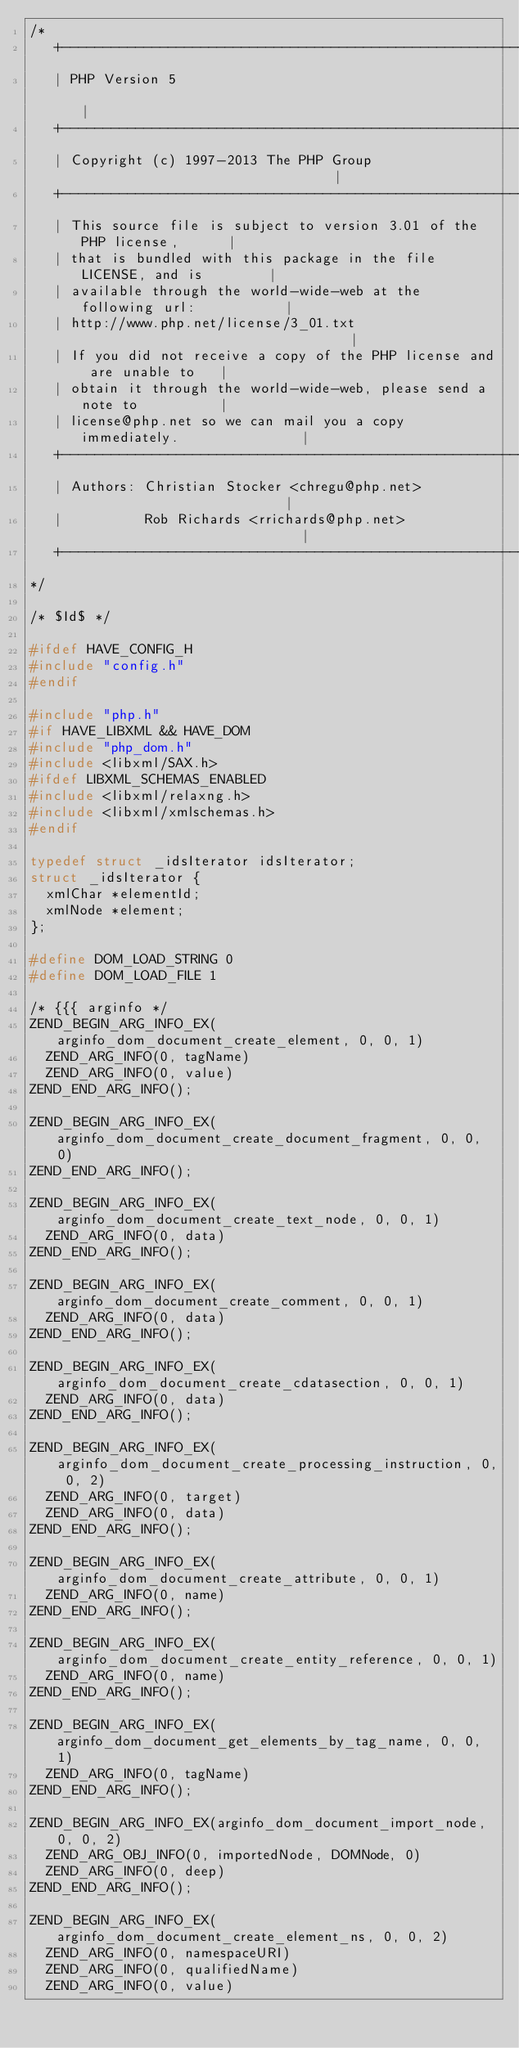Convert code to text. <code><loc_0><loc_0><loc_500><loc_500><_C_>/*
   +----------------------------------------------------------------------+
   | PHP Version 5                                                        |
   +----------------------------------------------------------------------+
   | Copyright (c) 1997-2013 The PHP Group                                |
   +----------------------------------------------------------------------+
   | This source file is subject to version 3.01 of the PHP license,      |
   | that is bundled with this package in the file LICENSE, and is        |
   | available through the world-wide-web at the following url:           |
   | http://www.php.net/license/3_01.txt                                  |
   | If you did not receive a copy of the PHP license and are unable to   |
   | obtain it through the world-wide-web, please send a note to          |
   | license@php.net so we can mail you a copy immediately.               |
   +----------------------------------------------------------------------+
   | Authors: Christian Stocker <chregu@php.net>                          |
   |          Rob Richards <rrichards@php.net>                            |
   +----------------------------------------------------------------------+
*/

/* $Id$ */

#ifdef HAVE_CONFIG_H
#include "config.h"
#endif

#include "php.h"
#if HAVE_LIBXML && HAVE_DOM
#include "php_dom.h"
#include <libxml/SAX.h>
#ifdef LIBXML_SCHEMAS_ENABLED
#include <libxml/relaxng.h>
#include <libxml/xmlschemas.h>
#endif

typedef struct _idsIterator idsIterator;
struct _idsIterator {
	xmlChar *elementId;
	xmlNode *element;
};

#define DOM_LOAD_STRING 0
#define DOM_LOAD_FILE 1

/* {{{ arginfo */
ZEND_BEGIN_ARG_INFO_EX(arginfo_dom_document_create_element, 0, 0, 1)
	ZEND_ARG_INFO(0, tagName)
	ZEND_ARG_INFO(0, value)
ZEND_END_ARG_INFO();

ZEND_BEGIN_ARG_INFO_EX(arginfo_dom_document_create_document_fragment, 0, 0, 0)
ZEND_END_ARG_INFO();

ZEND_BEGIN_ARG_INFO_EX(arginfo_dom_document_create_text_node, 0, 0, 1)
	ZEND_ARG_INFO(0, data)
ZEND_END_ARG_INFO();

ZEND_BEGIN_ARG_INFO_EX(arginfo_dom_document_create_comment, 0, 0, 1)
	ZEND_ARG_INFO(0, data)
ZEND_END_ARG_INFO();

ZEND_BEGIN_ARG_INFO_EX(arginfo_dom_document_create_cdatasection, 0, 0, 1)
	ZEND_ARG_INFO(0, data)
ZEND_END_ARG_INFO();

ZEND_BEGIN_ARG_INFO_EX(arginfo_dom_document_create_processing_instruction, 0, 0, 2)
	ZEND_ARG_INFO(0, target)
	ZEND_ARG_INFO(0, data)
ZEND_END_ARG_INFO();

ZEND_BEGIN_ARG_INFO_EX(arginfo_dom_document_create_attribute, 0, 0, 1)
	ZEND_ARG_INFO(0, name)
ZEND_END_ARG_INFO();

ZEND_BEGIN_ARG_INFO_EX(arginfo_dom_document_create_entity_reference, 0, 0, 1)
	ZEND_ARG_INFO(0, name)
ZEND_END_ARG_INFO();

ZEND_BEGIN_ARG_INFO_EX(arginfo_dom_document_get_elements_by_tag_name, 0, 0, 1)
	ZEND_ARG_INFO(0, tagName)
ZEND_END_ARG_INFO();

ZEND_BEGIN_ARG_INFO_EX(arginfo_dom_document_import_node, 0, 0, 2)
	ZEND_ARG_OBJ_INFO(0, importedNode, DOMNode, 0)
	ZEND_ARG_INFO(0, deep)
ZEND_END_ARG_INFO();

ZEND_BEGIN_ARG_INFO_EX(arginfo_dom_document_create_element_ns, 0, 0, 2)
	ZEND_ARG_INFO(0, namespaceURI)
	ZEND_ARG_INFO(0, qualifiedName)
	ZEND_ARG_INFO(0, value)</code> 